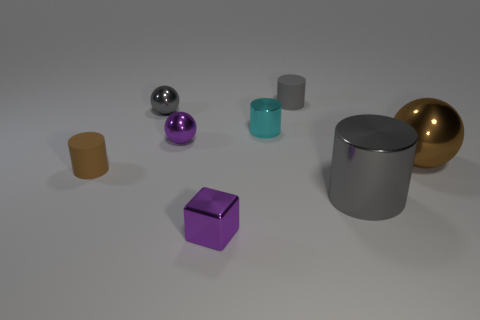Subtract 1 cylinders. How many cylinders are left? 3 Add 2 large yellow metal cubes. How many objects exist? 10 Subtract all blocks. How many objects are left? 7 Add 6 small shiny cylinders. How many small shiny cylinders are left? 7 Add 7 brown cylinders. How many brown cylinders exist? 8 Subtract 1 gray spheres. How many objects are left? 7 Subtract all yellow metal cylinders. Subtract all brown shiny balls. How many objects are left? 7 